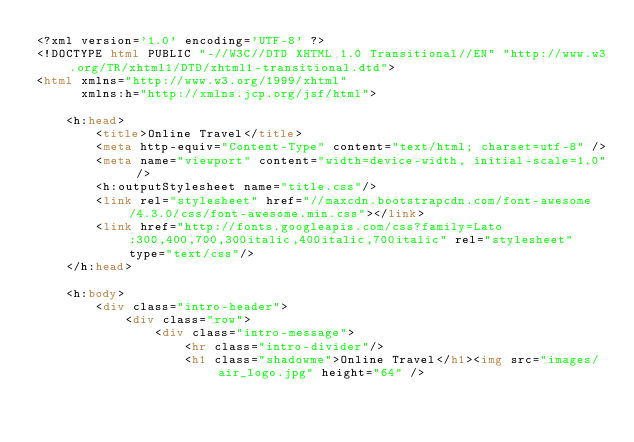<code> <loc_0><loc_0><loc_500><loc_500><_HTML_><?xml version='1.0' encoding='UTF-8' ?>
<!DOCTYPE html PUBLIC "-//W3C//DTD XHTML 1.0 Transitional//EN" "http://www.w3.org/TR/xhtml1/DTD/xhtml1-transitional.dtd">
<html xmlns="http://www.w3.org/1999/xhtml"
      xmlns:h="http://xmlns.jcp.org/jsf/html">

    <h:head>
        <title>Online Travel</title>
        <meta http-equiv="Content-Type" content="text/html; charset=utf-8" />
        <meta name="viewport" content="width=device-width, initial-scale=1.0" />
        <h:outputStylesheet name="title.css"/>
        <link rel="stylesheet" href="//maxcdn.bootstrapcdn.com/font-awesome/4.3.0/css/font-awesome.min.css"></link>
        <link href="http://fonts.googleapis.com/css?family=Lato:300,400,700,300italic,400italic,700italic" rel="stylesheet" type="text/css"/>
    </h:head>

    <h:body>
        <div class="intro-header">
            <div class="row">
                <div class="intro-message">
                    <hr class="intro-divider"/>
                    <h1 class="shadowme">Online Travel</h1><img src="images/air_logo.jpg" height="64" /></code> 